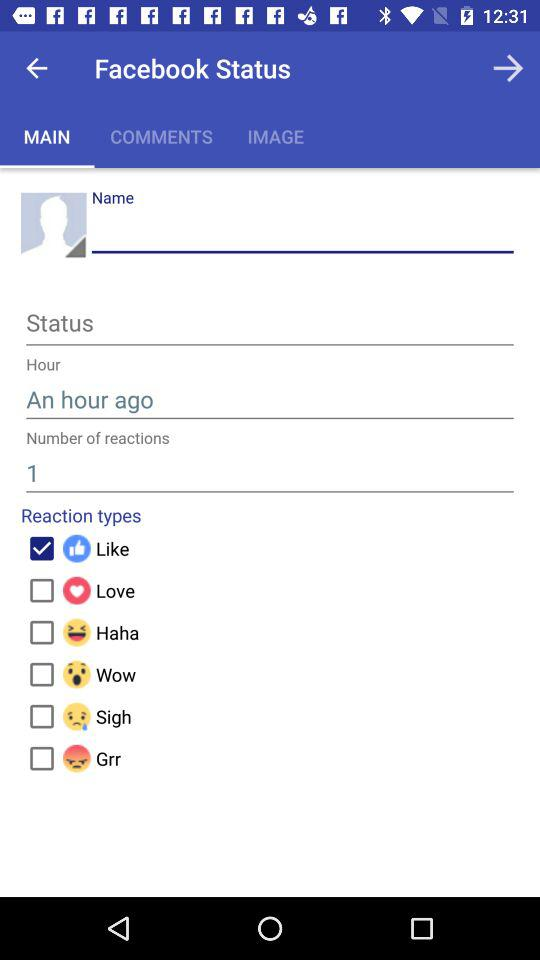Which type of reaction is selected? The selected type of reaction is "Like". 